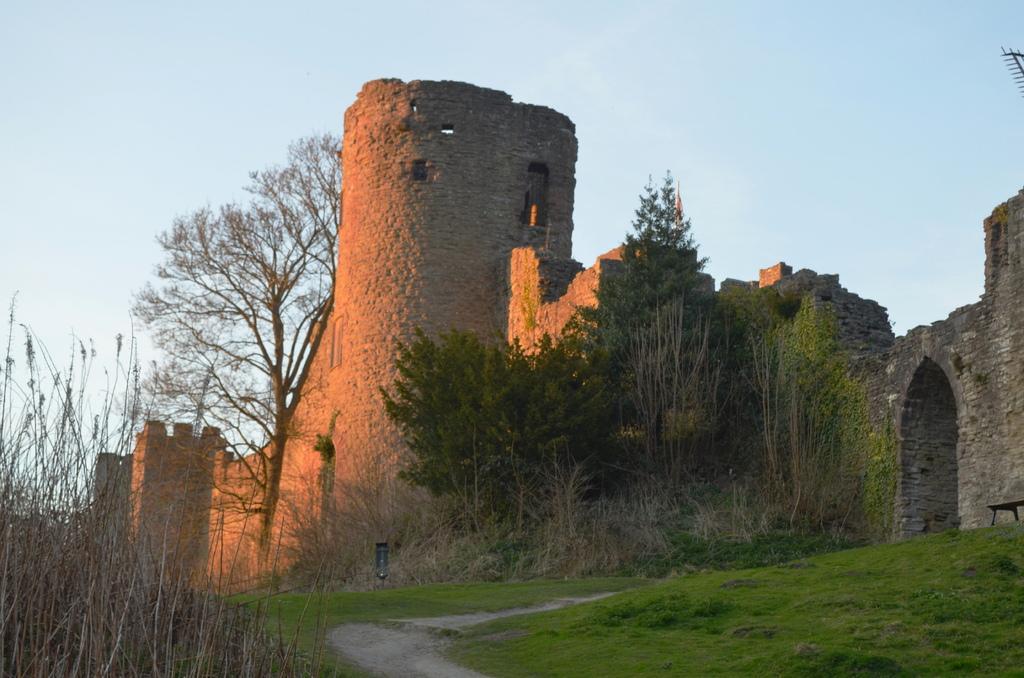Describe this image in one or two sentences. In this image in front there is grass on the surface. In the background of the image there are buildings, trees and sky. 